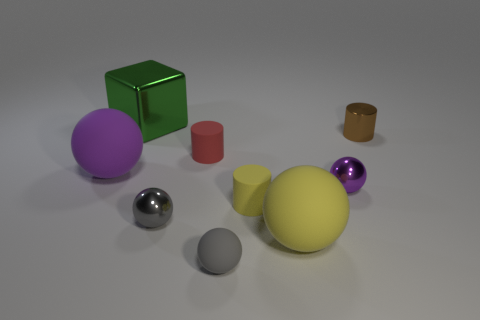Subtract all small gray metallic balls. How many balls are left? 4 Subtract all brown balls. Subtract all yellow cubes. How many balls are left? 5 Add 1 tiny red matte cylinders. How many objects exist? 10 Subtract all cylinders. How many objects are left? 6 Subtract 0 blue cylinders. How many objects are left? 9 Subtract all small metallic cylinders. Subtract all large purple rubber objects. How many objects are left? 7 Add 1 purple metal balls. How many purple metal balls are left? 2 Add 6 big blocks. How many big blocks exist? 7 